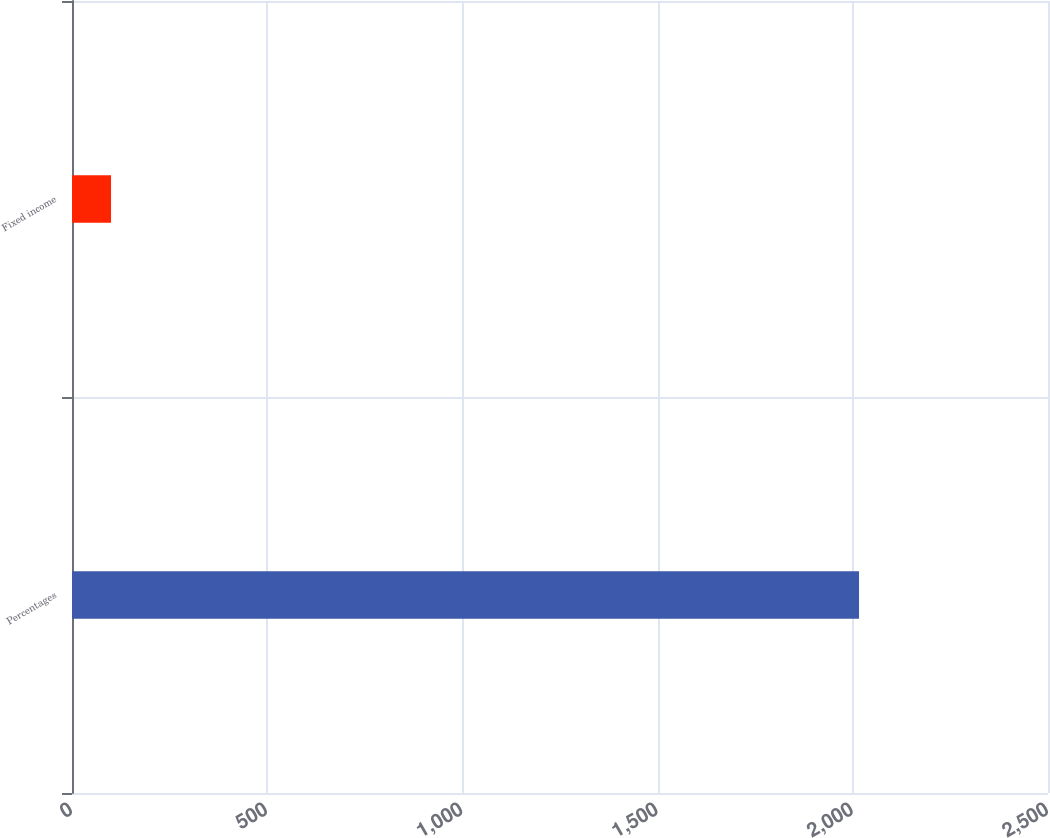Convert chart to OTSL. <chart><loc_0><loc_0><loc_500><loc_500><bar_chart><fcel>Percentages<fcel>Fixed income<nl><fcel>2016<fcel>100<nl></chart> 